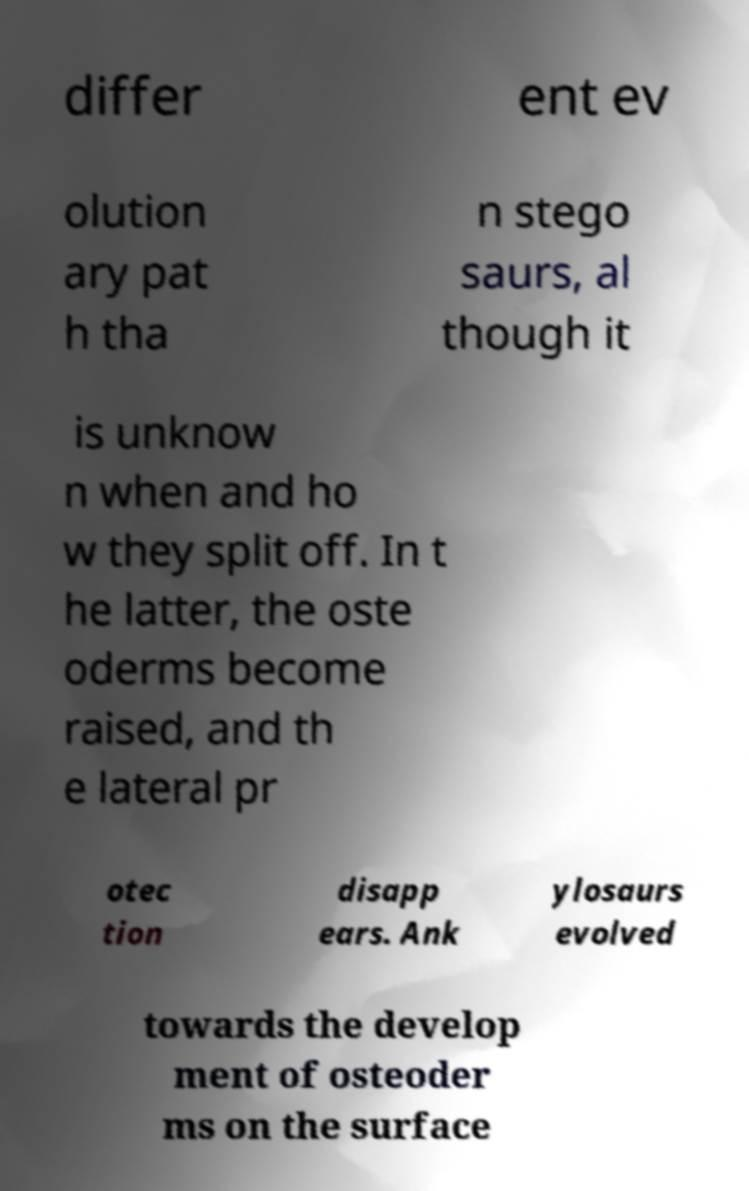Please read and relay the text visible in this image. What does it say? differ ent ev olution ary pat h tha n stego saurs, al though it is unknow n when and ho w they split off. In t he latter, the oste oderms become raised, and th e lateral pr otec tion disapp ears. Ank ylosaurs evolved towards the develop ment of osteoder ms on the surface 